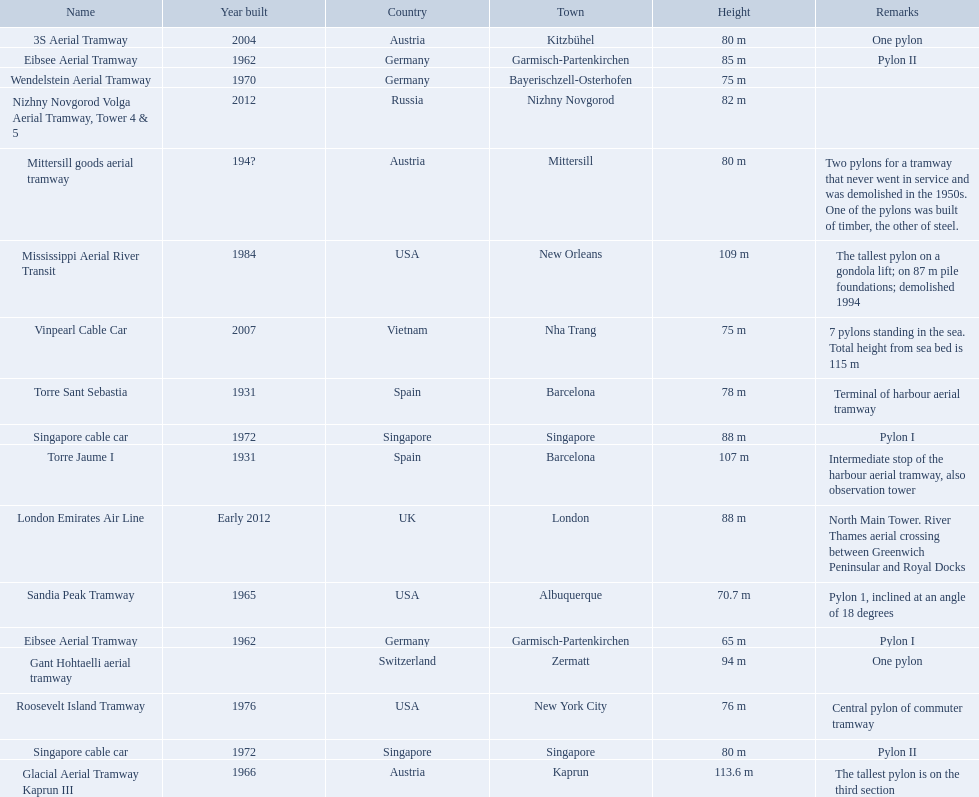Which aerial lifts are over 100 meters tall? Glacial Aerial Tramway Kaprun III, Mississippi Aerial River Transit, Torre Jaume I. Which of those was built last? Mississippi Aerial River Transit. And what is its total height? 109 m. 